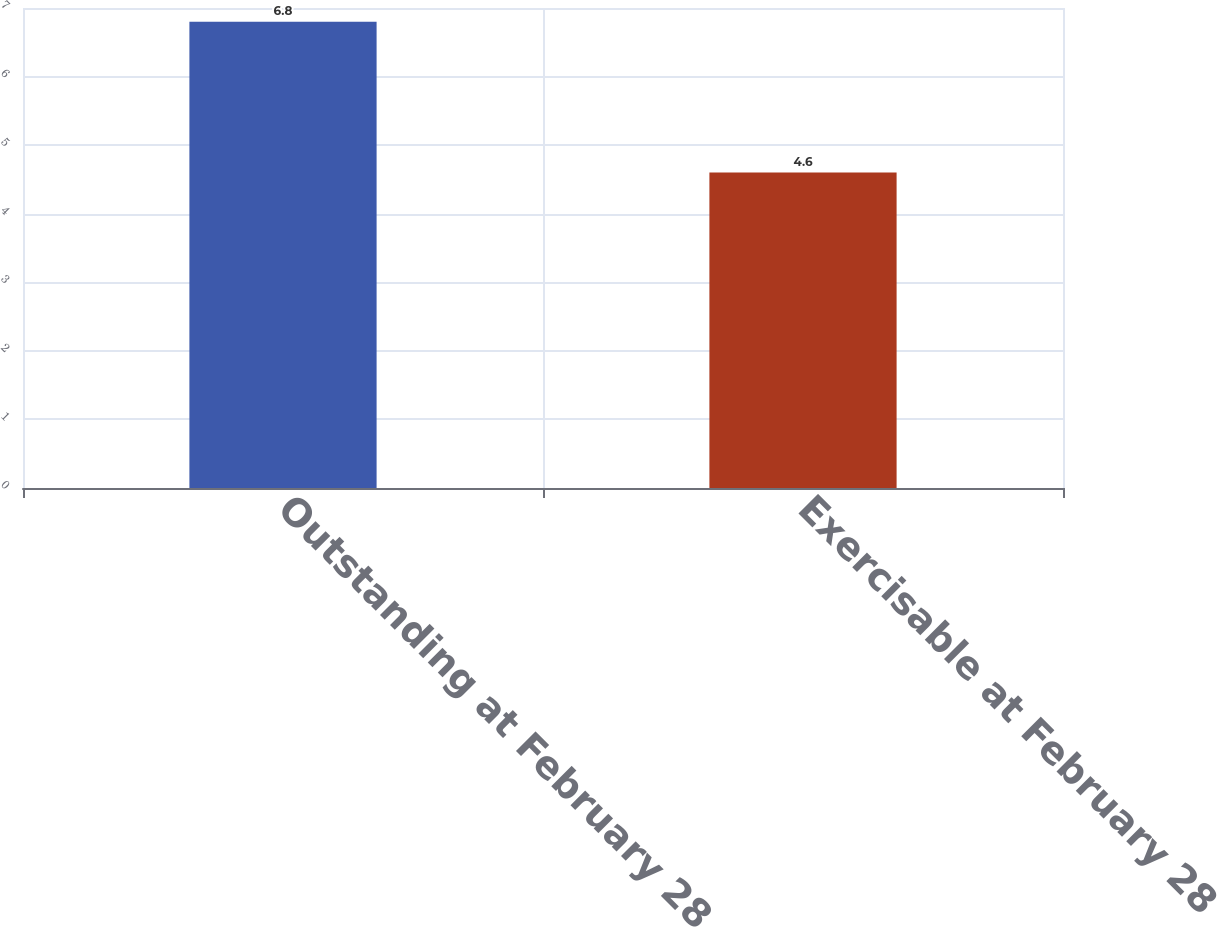Convert chart. <chart><loc_0><loc_0><loc_500><loc_500><bar_chart><fcel>Outstanding at February 28<fcel>Exercisable at February 28<nl><fcel>6.8<fcel>4.6<nl></chart> 